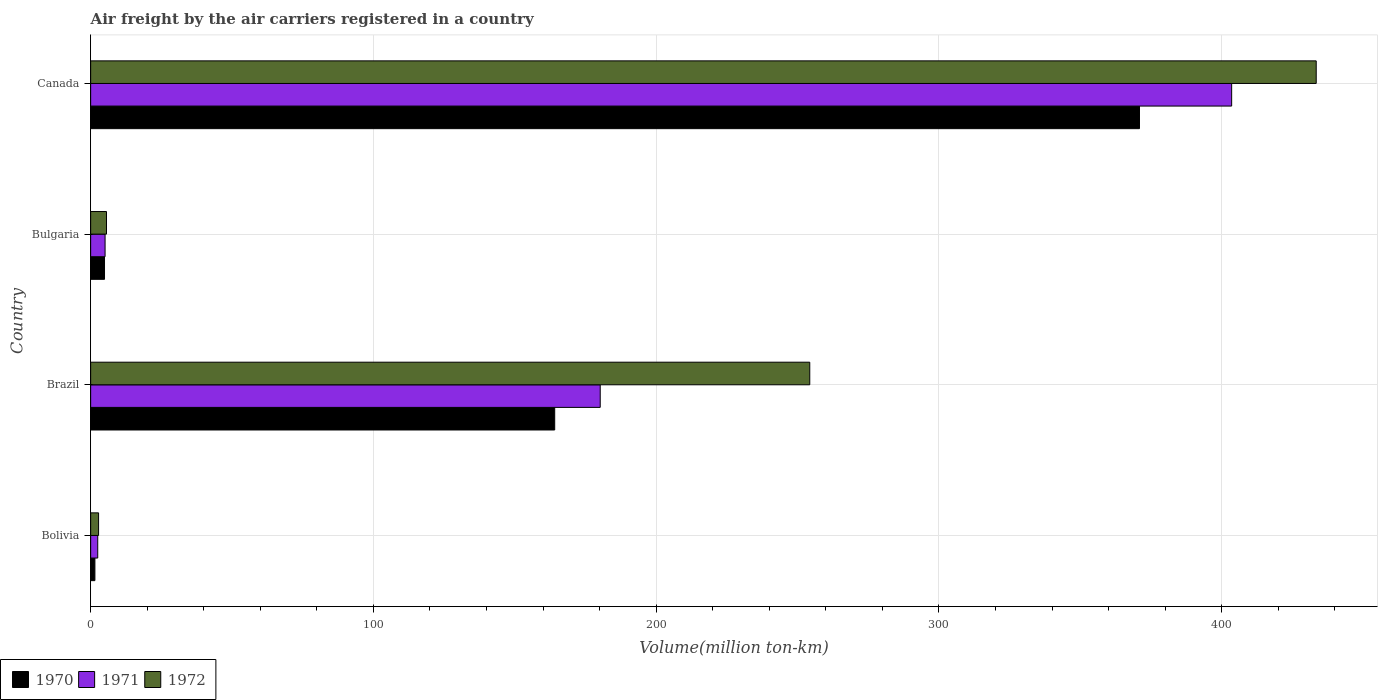How many different coloured bars are there?
Your response must be concise. 3. How many groups of bars are there?
Your response must be concise. 4. Are the number of bars per tick equal to the number of legend labels?
Your response must be concise. Yes. Are the number of bars on each tick of the Y-axis equal?
Provide a short and direct response. Yes. How many bars are there on the 3rd tick from the bottom?
Your response must be concise. 3. In how many cases, is the number of bars for a given country not equal to the number of legend labels?
Offer a very short reply. 0. What is the volume of the air carriers in 1972 in Brazil?
Offer a very short reply. 254.3. Across all countries, what is the maximum volume of the air carriers in 1970?
Offer a very short reply. 370.9. In which country was the volume of the air carriers in 1970 maximum?
Make the answer very short. Canada. What is the total volume of the air carriers in 1972 in the graph?
Your response must be concise. 696.1. What is the difference between the volume of the air carriers in 1972 in Bolivia and that in Canada?
Your response must be concise. -430.6. What is the difference between the volume of the air carriers in 1972 in Canada and the volume of the air carriers in 1970 in Brazil?
Ensure brevity in your answer.  269.3. What is the average volume of the air carriers in 1971 per country?
Offer a very short reply. 147.82. What is the difference between the volume of the air carriers in 1972 and volume of the air carriers in 1971 in Bulgaria?
Keep it short and to the point. 0.5. In how many countries, is the volume of the air carriers in 1972 greater than 240 million ton-km?
Provide a short and direct response. 2. What is the ratio of the volume of the air carriers in 1971 in Brazil to that in Bulgaria?
Give a very brief answer. 35.33. Is the volume of the air carriers in 1971 in Brazil less than that in Canada?
Provide a succinct answer. Yes. Is the difference between the volume of the air carriers in 1972 in Bolivia and Bulgaria greater than the difference between the volume of the air carriers in 1971 in Bolivia and Bulgaria?
Your response must be concise. No. What is the difference between the highest and the second highest volume of the air carriers in 1971?
Your answer should be very brief. 223.3. What is the difference between the highest and the lowest volume of the air carriers in 1970?
Your response must be concise. 369.4. Is the sum of the volume of the air carriers in 1970 in Bolivia and Canada greater than the maximum volume of the air carriers in 1971 across all countries?
Offer a terse response. No. What does the 1st bar from the top in Brazil represents?
Make the answer very short. 1972. Is it the case that in every country, the sum of the volume of the air carriers in 1970 and volume of the air carriers in 1971 is greater than the volume of the air carriers in 1972?
Offer a terse response. Yes. How many bars are there?
Ensure brevity in your answer.  12. Are all the bars in the graph horizontal?
Give a very brief answer. Yes. How many countries are there in the graph?
Offer a terse response. 4. Are the values on the major ticks of X-axis written in scientific E-notation?
Make the answer very short. No. How many legend labels are there?
Offer a terse response. 3. How are the legend labels stacked?
Your response must be concise. Horizontal. What is the title of the graph?
Your response must be concise. Air freight by the air carriers registered in a country. What is the label or title of the X-axis?
Ensure brevity in your answer.  Volume(million ton-km). What is the Volume(million ton-km) in 1971 in Bolivia?
Give a very brief answer. 2.5. What is the Volume(million ton-km) in 1972 in Bolivia?
Make the answer very short. 2.8. What is the Volume(million ton-km) in 1970 in Brazil?
Your answer should be very brief. 164.1. What is the Volume(million ton-km) of 1971 in Brazil?
Make the answer very short. 180.2. What is the Volume(million ton-km) in 1972 in Brazil?
Provide a succinct answer. 254.3. What is the Volume(million ton-km) of 1970 in Bulgaria?
Keep it short and to the point. 4.9. What is the Volume(million ton-km) of 1971 in Bulgaria?
Make the answer very short. 5.1. What is the Volume(million ton-km) of 1972 in Bulgaria?
Make the answer very short. 5.6. What is the Volume(million ton-km) of 1970 in Canada?
Make the answer very short. 370.9. What is the Volume(million ton-km) in 1971 in Canada?
Your answer should be very brief. 403.5. What is the Volume(million ton-km) of 1972 in Canada?
Give a very brief answer. 433.4. Across all countries, what is the maximum Volume(million ton-km) in 1970?
Offer a very short reply. 370.9. Across all countries, what is the maximum Volume(million ton-km) in 1971?
Give a very brief answer. 403.5. Across all countries, what is the maximum Volume(million ton-km) in 1972?
Your answer should be very brief. 433.4. Across all countries, what is the minimum Volume(million ton-km) of 1971?
Give a very brief answer. 2.5. Across all countries, what is the minimum Volume(million ton-km) of 1972?
Offer a very short reply. 2.8. What is the total Volume(million ton-km) in 1970 in the graph?
Your response must be concise. 541.4. What is the total Volume(million ton-km) in 1971 in the graph?
Your response must be concise. 591.3. What is the total Volume(million ton-km) of 1972 in the graph?
Your response must be concise. 696.1. What is the difference between the Volume(million ton-km) of 1970 in Bolivia and that in Brazil?
Offer a terse response. -162.6. What is the difference between the Volume(million ton-km) of 1971 in Bolivia and that in Brazil?
Make the answer very short. -177.7. What is the difference between the Volume(million ton-km) of 1972 in Bolivia and that in Brazil?
Your response must be concise. -251.5. What is the difference between the Volume(million ton-km) in 1970 in Bolivia and that in Canada?
Keep it short and to the point. -369.4. What is the difference between the Volume(million ton-km) in 1971 in Bolivia and that in Canada?
Your response must be concise. -401. What is the difference between the Volume(million ton-km) of 1972 in Bolivia and that in Canada?
Your answer should be compact. -430.6. What is the difference between the Volume(million ton-km) in 1970 in Brazil and that in Bulgaria?
Keep it short and to the point. 159.2. What is the difference between the Volume(million ton-km) in 1971 in Brazil and that in Bulgaria?
Offer a very short reply. 175.1. What is the difference between the Volume(million ton-km) of 1972 in Brazil and that in Bulgaria?
Ensure brevity in your answer.  248.7. What is the difference between the Volume(million ton-km) of 1970 in Brazil and that in Canada?
Provide a succinct answer. -206.8. What is the difference between the Volume(million ton-km) in 1971 in Brazil and that in Canada?
Provide a short and direct response. -223.3. What is the difference between the Volume(million ton-km) in 1972 in Brazil and that in Canada?
Make the answer very short. -179.1. What is the difference between the Volume(million ton-km) of 1970 in Bulgaria and that in Canada?
Your answer should be compact. -366. What is the difference between the Volume(million ton-km) of 1971 in Bulgaria and that in Canada?
Make the answer very short. -398.4. What is the difference between the Volume(million ton-km) of 1972 in Bulgaria and that in Canada?
Ensure brevity in your answer.  -427.8. What is the difference between the Volume(million ton-km) in 1970 in Bolivia and the Volume(million ton-km) in 1971 in Brazil?
Ensure brevity in your answer.  -178.7. What is the difference between the Volume(million ton-km) of 1970 in Bolivia and the Volume(million ton-km) of 1972 in Brazil?
Your answer should be very brief. -252.8. What is the difference between the Volume(million ton-km) in 1971 in Bolivia and the Volume(million ton-km) in 1972 in Brazil?
Offer a terse response. -251.8. What is the difference between the Volume(million ton-km) in 1970 in Bolivia and the Volume(million ton-km) in 1971 in Bulgaria?
Provide a succinct answer. -3.6. What is the difference between the Volume(million ton-km) of 1970 in Bolivia and the Volume(million ton-km) of 1971 in Canada?
Make the answer very short. -402. What is the difference between the Volume(million ton-km) in 1970 in Bolivia and the Volume(million ton-km) in 1972 in Canada?
Your answer should be compact. -431.9. What is the difference between the Volume(million ton-km) of 1971 in Bolivia and the Volume(million ton-km) of 1972 in Canada?
Keep it short and to the point. -430.9. What is the difference between the Volume(million ton-km) of 1970 in Brazil and the Volume(million ton-km) of 1971 in Bulgaria?
Provide a succinct answer. 159. What is the difference between the Volume(million ton-km) in 1970 in Brazil and the Volume(million ton-km) in 1972 in Bulgaria?
Give a very brief answer. 158.5. What is the difference between the Volume(million ton-km) in 1971 in Brazil and the Volume(million ton-km) in 1972 in Bulgaria?
Your answer should be compact. 174.6. What is the difference between the Volume(million ton-km) of 1970 in Brazil and the Volume(million ton-km) of 1971 in Canada?
Make the answer very short. -239.4. What is the difference between the Volume(million ton-km) in 1970 in Brazil and the Volume(million ton-km) in 1972 in Canada?
Offer a very short reply. -269.3. What is the difference between the Volume(million ton-km) of 1971 in Brazil and the Volume(million ton-km) of 1972 in Canada?
Offer a very short reply. -253.2. What is the difference between the Volume(million ton-km) of 1970 in Bulgaria and the Volume(million ton-km) of 1971 in Canada?
Give a very brief answer. -398.6. What is the difference between the Volume(million ton-km) in 1970 in Bulgaria and the Volume(million ton-km) in 1972 in Canada?
Provide a short and direct response. -428.5. What is the difference between the Volume(million ton-km) in 1971 in Bulgaria and the Volume(million ton-km) in 1972 in Canada?
Provide a succinct answer. -428.3. What is the average Volume(million ton-km) of 1970 per country?
Offer a terse response. 135.35. What is the average Volume(million ton-km) of 1971 per country?
Make the answer very short. 147.82. What is the average Volume(million ton-km) in 1972 per country?
Your response must be concise. 174.03. What is the difference between the Volume(million ton-km) in 1970 and Volume(million ton-km) in 1971 in Bolivia?
Offer a very short reply. -1. What is the difference between the Volume(million ton-km) in 1970 and Volume(million ton-km) in 1972 in Bolivia?
Give a very brief answer. -1.3. What is the difference between the Volume(million ton-km) of 1970 and Volume(million ton-km) of 1971 in Brazil?
Give a very brief answer. -16.1. What is the difference between the Volume(million ton-km) of 1970 and Volume(million ton-km) of 1972 in Brazil?
Your answer should be compact. -90.2. What is the difference between the Volume(million ton-km) in 1971 and Volume(million ton-km) in 1972 in Brazil?
Your answer should be very brief. -74.1. What is the difference between the Volume(million ton-km) of 1970 and Volume(million ton-km) of 1971 in Bulgaria?
Offer a terse response. -0.2. What is the difference between the Volume(million ton-km) in 1970 and Volume(million ton-km) in 1972 in Bulgaria?
Keep it short and to the point. -0.7. What is the difference between the Volume(million ton-km) of 1970 and Volume(million ton-km) of 1971 in Canada?
Offer a very short reply. -32.6. What is the difference between the Volume(million ton-km) of 1970 and Volume(million ton-km) of 1972 in Canada?
Give a very brief answer. -62.5. What is the difference between the Volume(million ton-km) of 1971 and Volume(million ton-km) of 1972 in Canada?
Offer a very short reply. -29.9. What is the ratio of the Volume(million ton-km) in 1970 in Bolivia to that in Brazil?
Keep it short and to the point. 0.01. What is the ratio of the Volume(million ton-km) in 1971 in Bolivia to that in Brazil?
Your answer should be compact. 0.01. What is the ratio of the Volume(million ton-km) in 1972 in Bolivia to that in Brazil?
Ensure brevity in your answer.  0.01. What is the ratio of the Volume(million ton-km) in 1970 in Bolivia to that in Bulgaria?
Offer a very short reply. 0.31. What is the ratio of the Volume(million ton-km) in 1971 in Bolivia to that in Bulgaria?
Provide a succinct answer. 0.49. What is the ratio of the Volume(million ton-km) of 1972 in Bolivia to that in Bulgaria?
Provide a succinct answer. 0.5. What is the ratio of the Volume(million ton-km) in 1970 in Bolivia to that in Canada?
Make the answer very short. 0. What is the ratio of the Volume(million ton-km) in 1971 in Bolivia to that in Canada?
Provide a short and direct response. 0.01. What is the ratio of the Volume(million ton-km) of 1972 in Bolivia to that in Canada?
Your response must be concise. 0.01. What is the ratio of the Volume(million ton-km) in 1970 in Brazil to that in Bulgaria?
Offer a very short reply. 33.49. What is the ratio of the Volume(million ton-km) of 1971 in Brazil to that in Bulgaria?
Ensure brevity in your answer.  35.33. What is the ratio of the Volume(million ton-km) in 1972 in Brazil to that in Bulgaria?
Make the answer very short. 45.41. What is the ratio of the Volume(million ton-km) of 1970 in Brazil to that in Canada?
Offer a very short reply. 0.44. What is the ratio of the Volume(million ton-km) in 1971 in Brazil to that in Canada?
Provide a succinct answer. 0.45. What is the ratio of the Volume(million ton-km) of 1972 in Brazil to that in Canada?
Offer a terse response. 0.59. What is the ratio of the Volume(million ton-km) in 1970 in Bulgaria to that in Canada?
Offer a terse response. 0.01. What is the ratio of the Volume(million ton-km) in 1971 in Bulgaria to that in Canada?
Your response must be concise. 0.01. What is the ratio of the Volume(million ton-km) of 1972 in Bulgaria to that in Canada?
Your response must be concise. 0.01. What is the difference between the highest and the second highest Volume(million ton-km) of 1970?
Your response must be concise. 206.8. What is the difference between the highest and the second highest Volume(million ton-km) in 1971?
Your answer should be compact. 223.3. What is the difference between the highest and the second highest Volume(million ton-km) in 1972?
Ensure brevity in your answer.  179.1. What is the difference between the highest and the lowest Volume(million ton-km) in 1970?
Offer a very short reply. 369.4. What is the difference between the highest and the lowest Volume(million ton-km) of 1971?
Make the answer very short. 401. What is the difference between the highest and the lowest Volume(million ton-km) of 1972?
Keep it short and to the point. 430.6. 